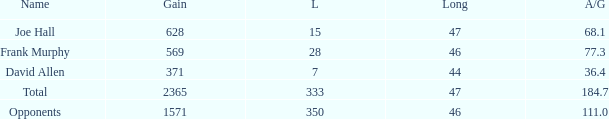Which Avg/G has a Name of david allen, and a Gain larger than 371? None. 